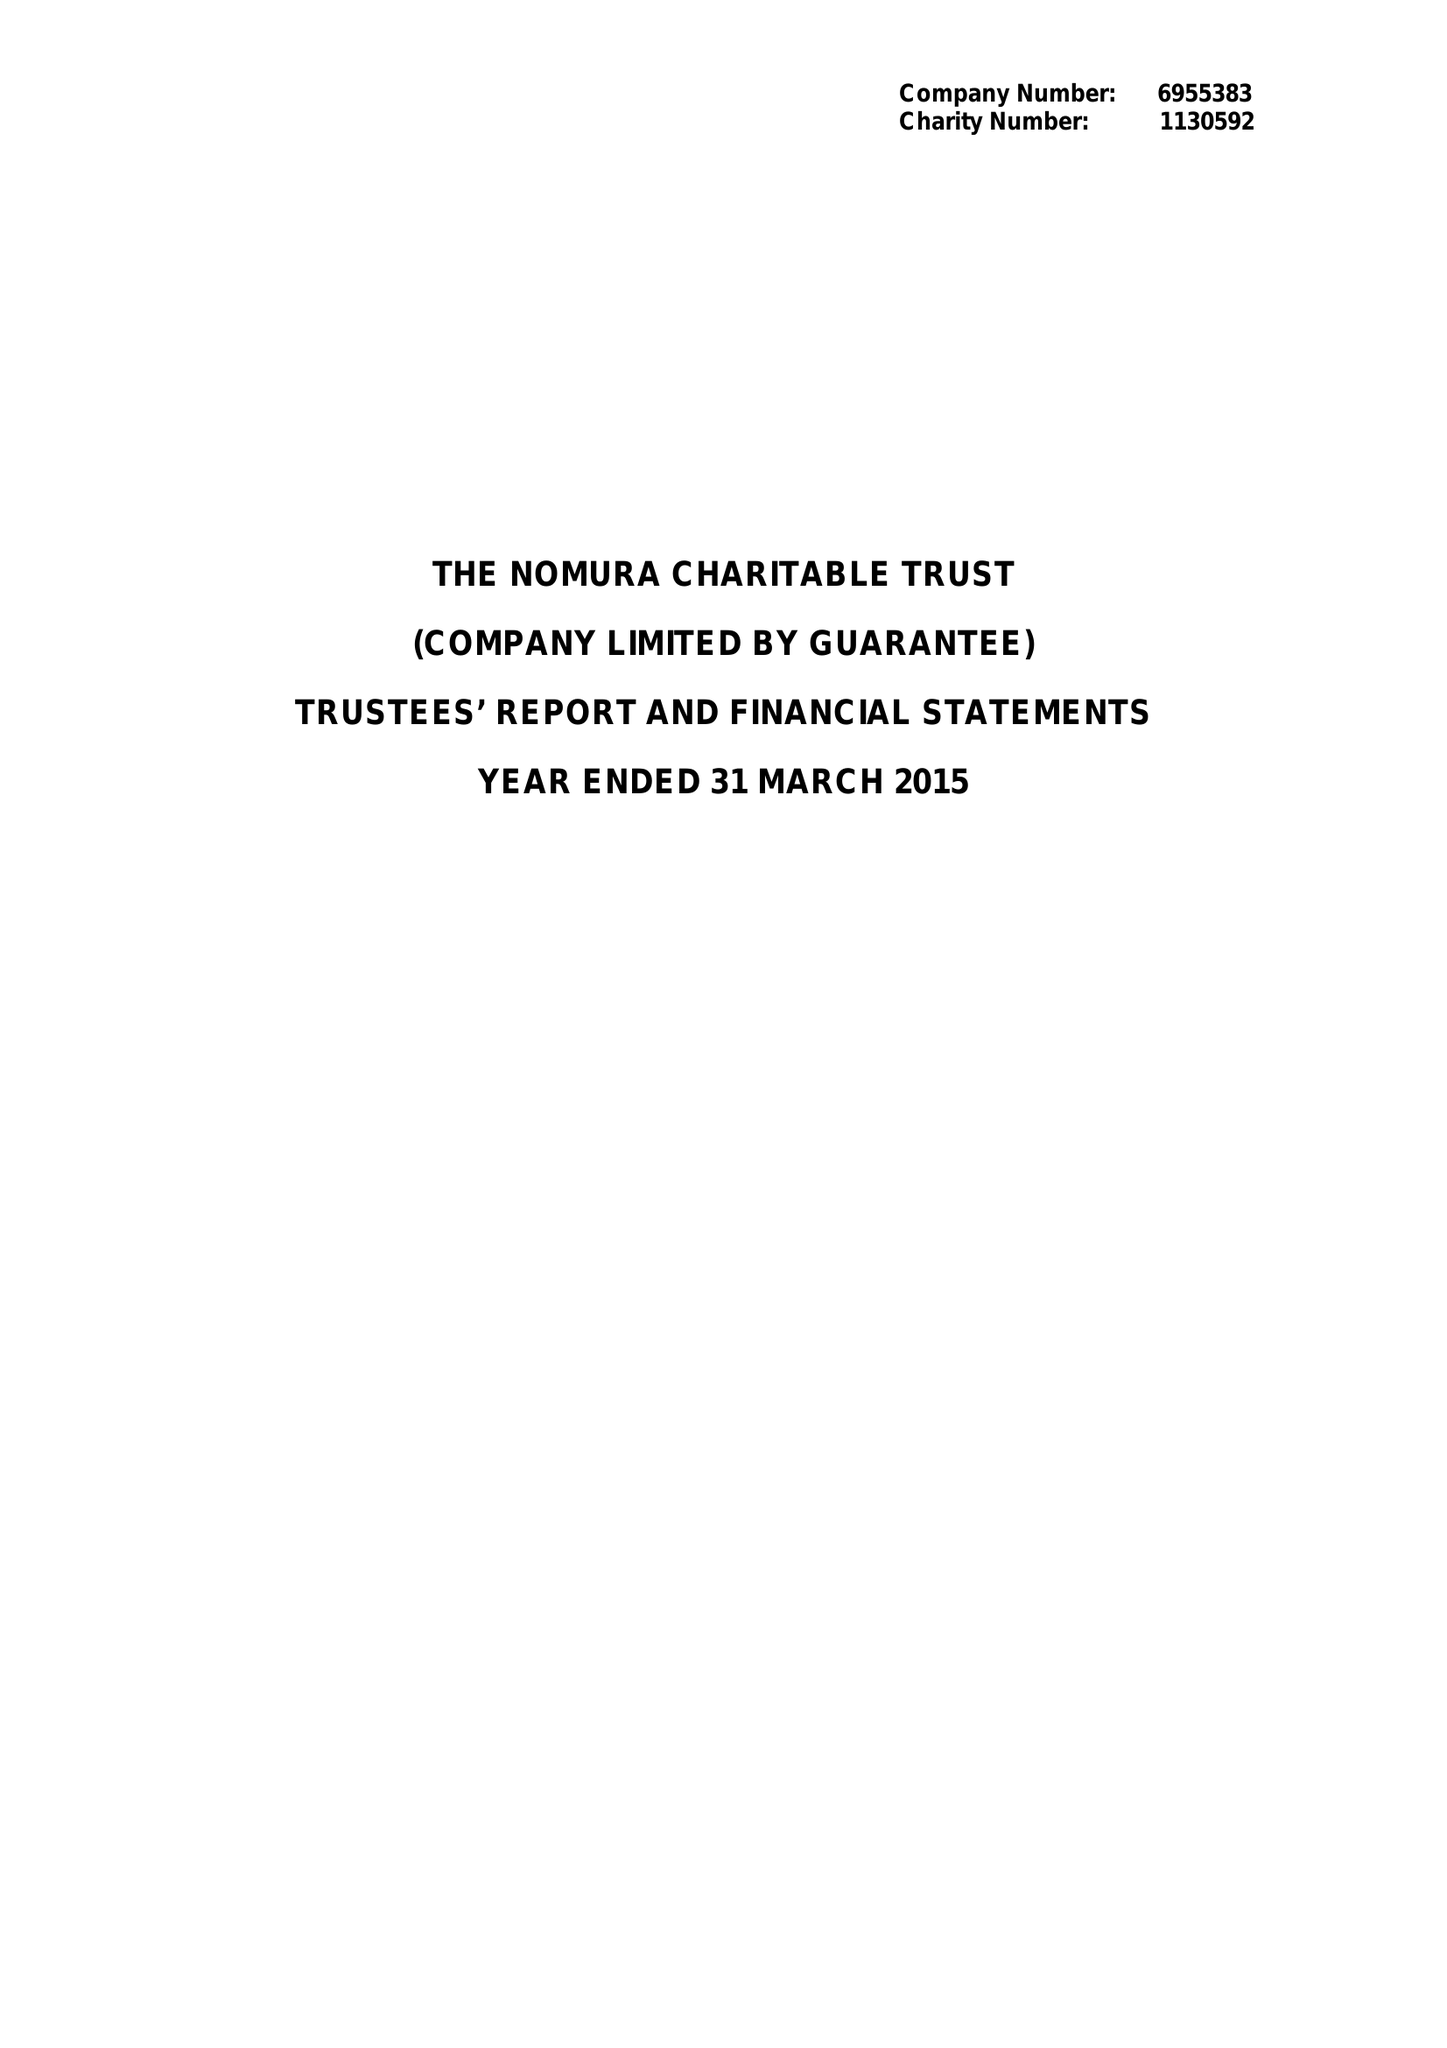What is the value for the income_annually_in_british_pounds?
Answer the question using a single word or phrase. 351559.00 